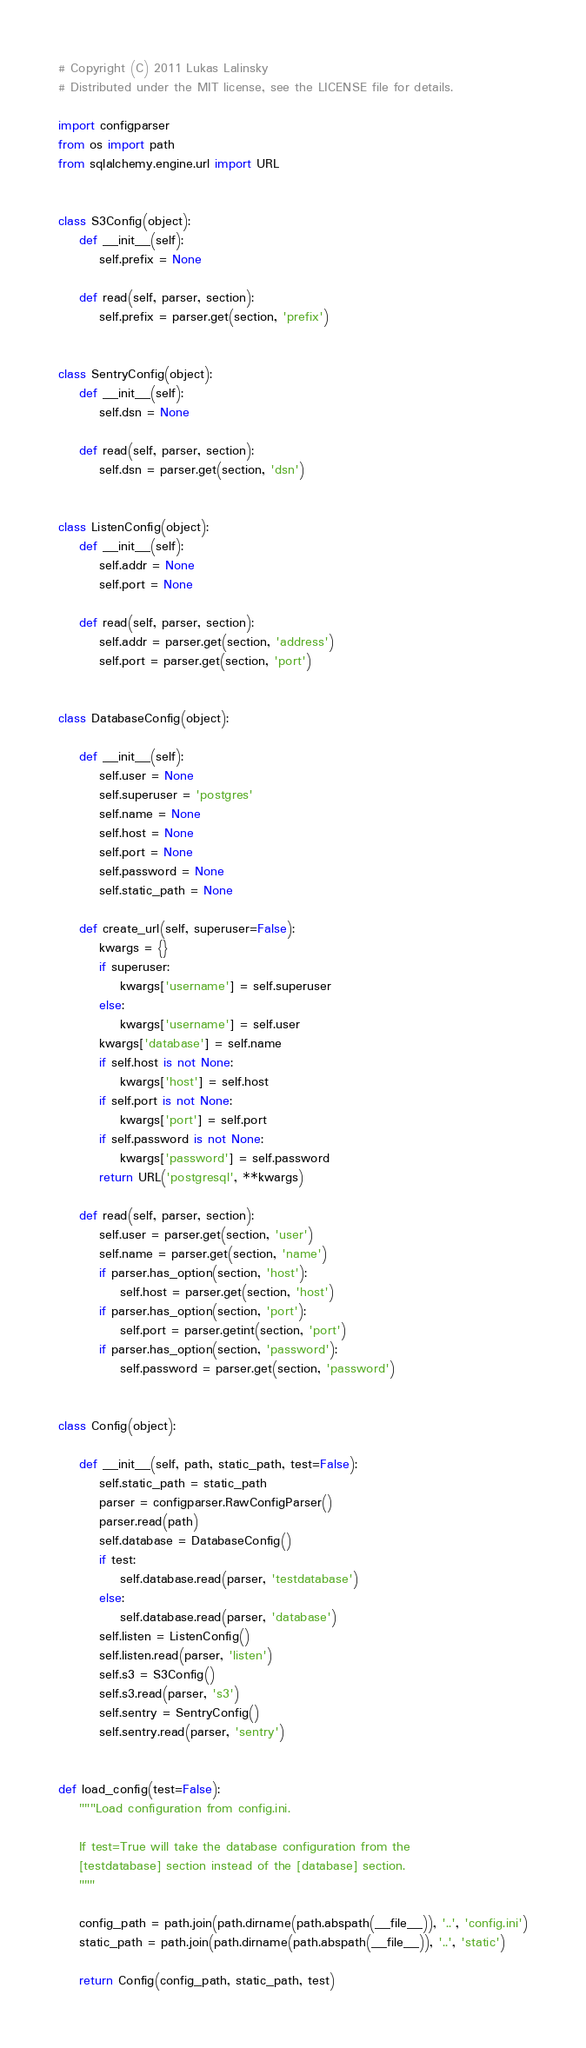<code> <loc_0><loc_0><loc_500><loc_500><_Python_># Copyright (C) 2011 Lukas Lalinsky
# Distributed under the MIT license, see the LICENSE file for details.

import configparser
from os import path
from sqlalchemy.engine.url import URL


class S3Config(object):
    def __init__(self):
        self.prefix = None

    def read(self, parser, section):
        self.prefix = parser.get(section, 'prefix')


class SentryConfig(object):
    def __init__(self):
        self.dsn = None

    def read(self, parser, section):
        self.dsn = parser.get(section, 'dsn')


class ListenConfig(object):
    def __init__(self):
        self.addr = None
        self.port = None

    def read(self, parser, section):
        self.addr = parser.get(section, 'address')
        self.port = parser.get(section, 'port')


class DatabaseConfig(object):

    def __init__(self):
        self.user = None
        self.superuser = 'postgres'
        self.name = None
        self.host = None
        self.port = None
        self.password = None
        self.static_path = None

    def create_url(self, superuser=False):
        kwargs = {}
        if superuser:
            kwargs['username'] = self.superuser
        else:
            kwargs['username'] = self.user
        kwargs['database'] = self.name
        if self.host is not None:
            kwargs['host'] = self.host
        if self.port is not None:
            kwargs['port'] = self.port
        if self.password is not None:
            kwargs['password'] = self.password
        return URL('postgresql', **kwargs)

    def read(self, parser, section):
        self.user = parser.get(section, 'user')
        self.name = parser.get(section, 'name')
        if parser.has_option(section, 'host'):
            self.host = parser.get(section, 'host')
        if parser.has_option(section, 'port'):
            self.port = parser.getint(section, 'port')
        if parser.has_option(section, 'password'):
            self.password = parser.get(section, 'password')


class Config(object):

    def __init__(self, path, static_path, test=False):
        self.static_path = static_path
        parser = configparser.RawConfigParser()
        parser.read(path)
        self.database = DatabaseConfig()
        if test:
            self.database.read(parser, 'testdatabase')
        else:
            self.database.read(parser, 'database')
        self.listen = ListenConfig()
        self.listen.read(parser, 'listen')
        self.s3 = S3Config()
        self.s3.read(parser, 's3')
        self.sentry = SentryConfig()
        self.sentry.read(parser, 'sentry')


def load_config(test=False):
    """Load configuration from config.ini.

    If test=True will take the database configuration from the
    [testdatabase] section instead of the [database] section.
    """

    config_path = path.join(path.dirname(path.abspath(__file__)), '..', 'config.ini')
    static_path = path.join(path.dirname(path.abspath(__file__)), '..', 'static')

    return Config(config_path, static_path, test)
</code> 